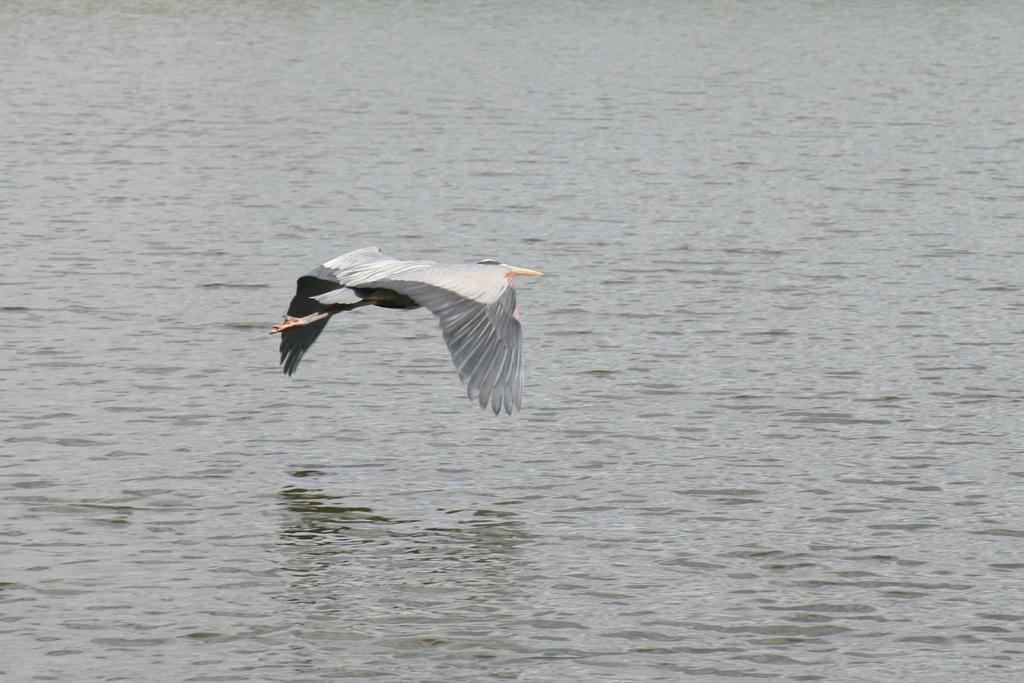What is the main subject of the image? The main subject of the image is a bird flying. What can be seen in the background of the image? There is a sea visible in the background of the image. What type of vest is the bird wearing in the image? There is no vest present on the bird in the image. What type of vessel can be seen sailing on the sea in the image? There is no vessel visible in the image; only the bird and the sea are present. 